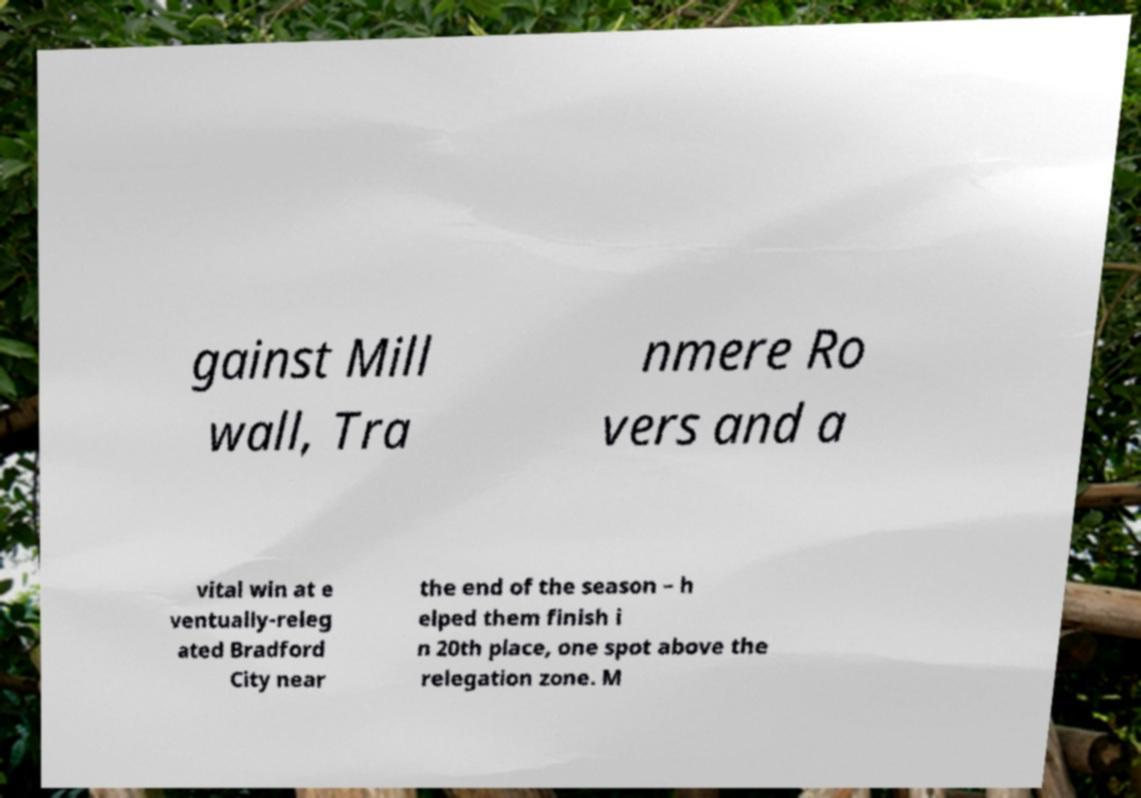For documentation purposes, I need the text within this image transcribed. Could you provide that? gainst Mill wall, Tra nmere Ro vers and a vital win at e ventually-releg ated Bradford City near the end of the season – h elped them finish i n 20th place, one spot above the relegation zone. M 